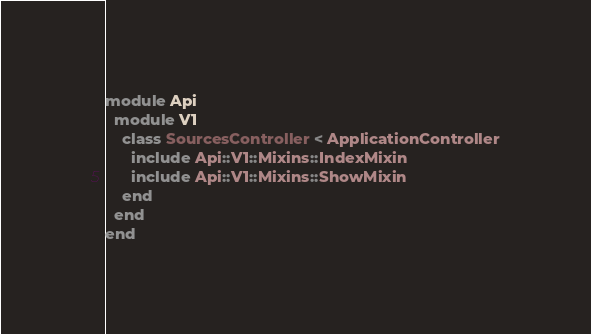Convert code to text. <code><loc_0><loc_0><loc_500><loc_500><_Ruby_>module Api
  module V1
    class SourcesController < ApplicationController
      include Api::V1::Mixins::IndexMixin
      include Api::V1::Mixins::ShowMixin
    end
  end
end
</code> 